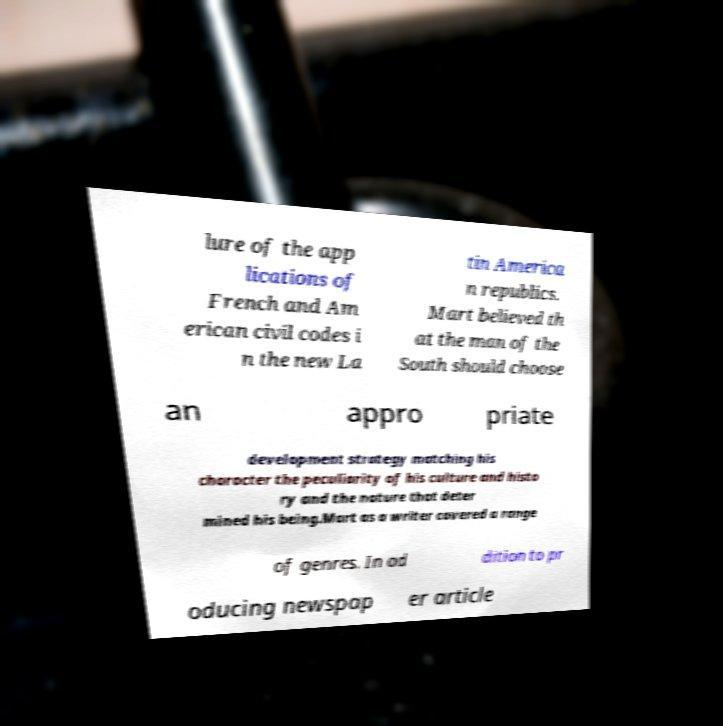I need the written content from this picture converted into text. Can you do that? lure of the app lications of French and Am erican civil codes i n the new La tin America n republics. Mart believed th at the man of the South should choose an appro priate development strategy matching his character the peculiarity of his culture and histo ry and the nature that deter mined his being.Mart as a writer covered a range of genres. In ad dition to pr oducing newspap er article 